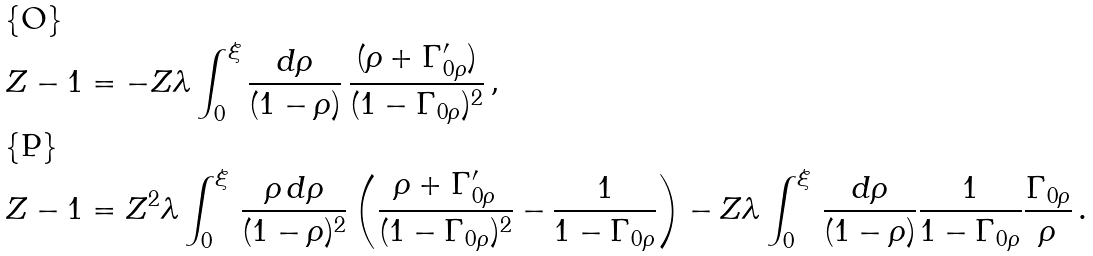Convert formula to latex. <formula><loc_0><loc_0><loc_500><loc_500>Z - 1 & = - Z \lambda \int _ { 0 } ^ { \xi } \frac { d \rho } { ( 1 - \rho ) } \, \frac { ( \rho + \Gamma ^ { \prime } _ { 0 \rho } ) } { ( 1 - \Gamma _ { 0 \rho } ) ^ { 2 } } \, , \\ Z - 1 & = Z ^ { 2 } \lambda \int _ { 0 } ^ { \xi } \, \frac { \rho \, d \rho } { ( 1 - \rho ) ^ { 2 } } \left ( \frac { \rho + \Gamma ^ { \prime } _ { 0 \rho } } { ( 1 - \Gamma _ { 0 \rho } ) ^ { 2 } } - \frac { 1 } { 1 - \Gamma _ { 0 \rho } } \right ) - Z \lambda \int _ { 0 } ^ { \xi } \, \frac { d \rho } { ( 1 - \rho ) } \frac { 1 } { 1 - \Gamma _ { 0 \rho } } \frac { \Gamma _ { 0 \rho } } { \rho } \, .</formula> 